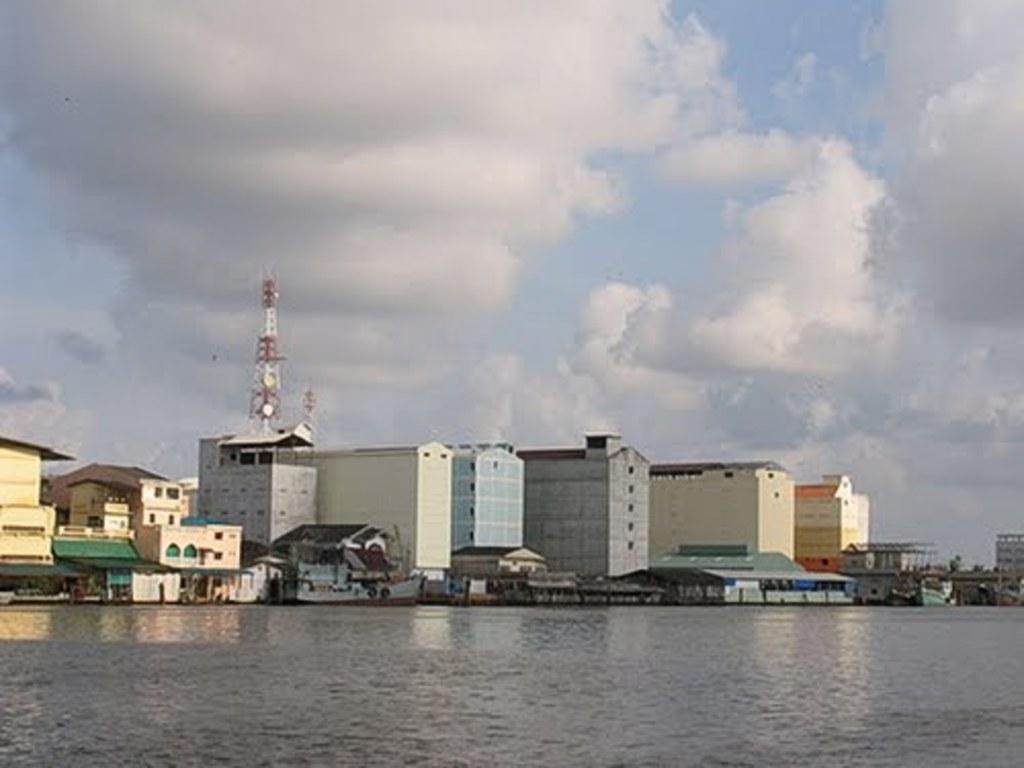What type of natural feature is present in the image? There is a lake in the image. What man-made structures can be seen in the image? There are buildings in the image. What is the condition of the sky in the image? The sky is covered with clouds. What additional feature can be seen behind the building? There is a tower behind the building. How many light bulbs are hanging from the trees in the image? There are no light bulbs present in the image; it features a lake, buildings, clouds, and a tower. What type of jelly can be seen floating on the lake in the image? There is no jelly present in the image; it features a lake, buildings, clouds, and a tower. 